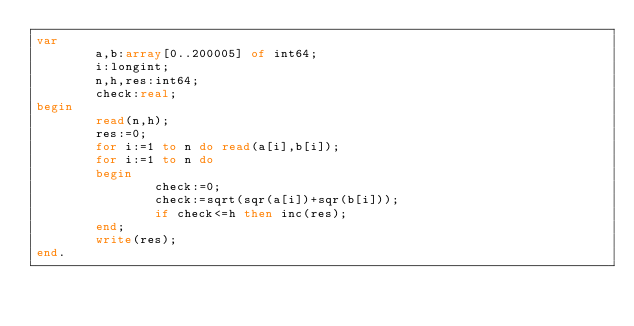<code> <loc_0><loc_0><loc_500><loc_500><_Pascal_>var
        a,b:array[0..200005] of int64;
        i:longint;
        n,h,res:int64;
        check:real;
begin
        read(n,h);
        res:=0;
        for i:=1 to n do read(a[i],b[i]);
        for i:=1 to n do
        begin
                check:=0;
                check:=sqrt(sqr(a[i])+sqr(b[i]));
                if check<=h then inc(res);
        end;
        write(res);
end.
</code> 